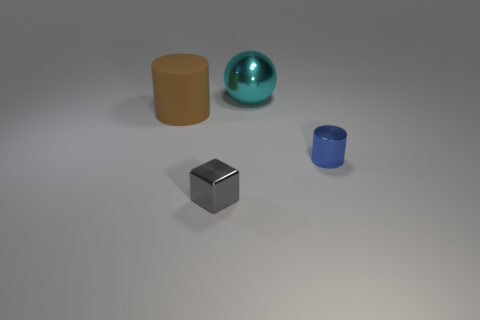There is a big brown matte cylinder; are there any blue objects left of it?
Provide a short and direct response. No. How many big cyan metallic objects are on the left side of the cylinder that is right of the cyan ball?
Your response must be concise. 1. There is a blue metallic cylinder; is its size the same as the cylinder that is on the left side of the blue cylinder?
Offer a terse response. No. What size is the cylinder that is the same material as the small gray cube?
Your answer should be very brief. Small. Do the small blue cylinder and the small gray thing have the same material?
Ensure brevity in your answer.  Yes. What is the color of the tiny thing in front of the cylinder that is on the right side of the shiny object behind the small blue metal thing?
Offer a very short reply. Gray. The blue thing is what shape?
Provide a short and direct response. Cylinder. Are there an equal number of blue metal cylinders behind the cyan metallic sphere and small metallic things?
Your answer should be very brief. No. How many rubber things have the same size as the brown matte cylinder?
Provide a short and direct response. 0. Are any spheres visible?
Your answer should be very brief. Yes. 